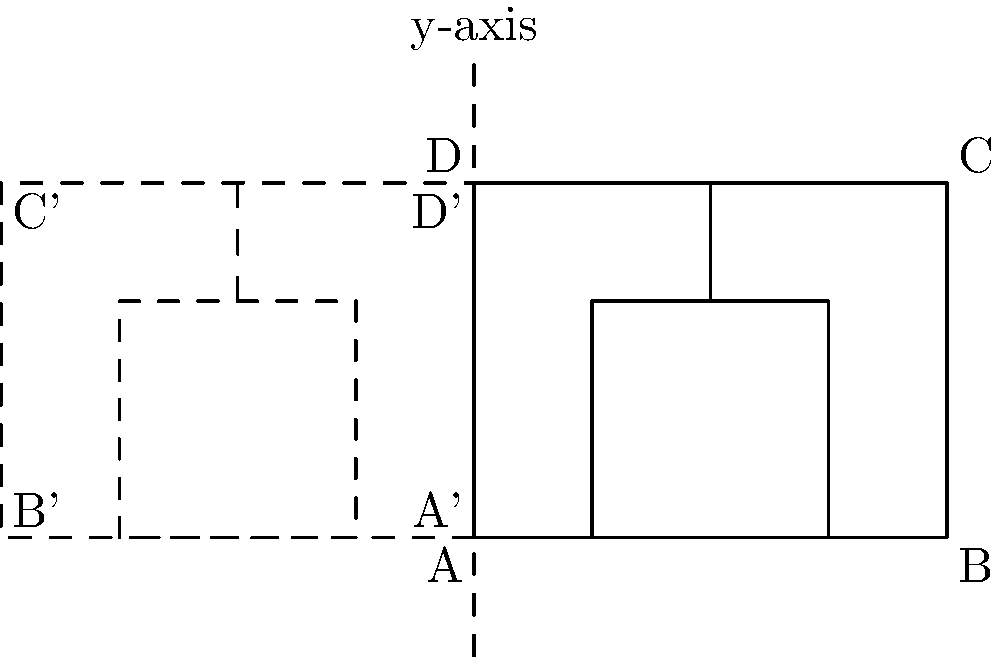As a pet owner, you decide to design a simple dog house for your low-maintenance pet. The original design is represented by the solid lines in the diagram, where ABCD is the outer frame and EFGH is the inner frame of the dog house. If you reflect this design across the y-axis to create a larger, symmetrical dog house, what will be the coordinates of point C' (the reflection of point C)? To find the coordinates of point C' after reflecting the dog house design across the y-axis, we can follow these steps:

1. Identify the original coordinates of point C:
   Point C is located at (4,3) in the original design.

2. Understand the reflection rule across the y-axis:
   When reflecting a point (x,y) across the y-axis, the new coordinates become (-x,y).

3. Apply the reflection rule to point C:
   C(4,3) becomes C'(-4,3)

4. Verify the result visually:
   In the diagram, we can see that C' is indeed located at (-4,3), which is symmetrical to C(4,3) with respect to the y-axis.

Therefore, the coordinates of point C' after reflection across the y-axis are (-4,3).
Answer: (-4,3) 